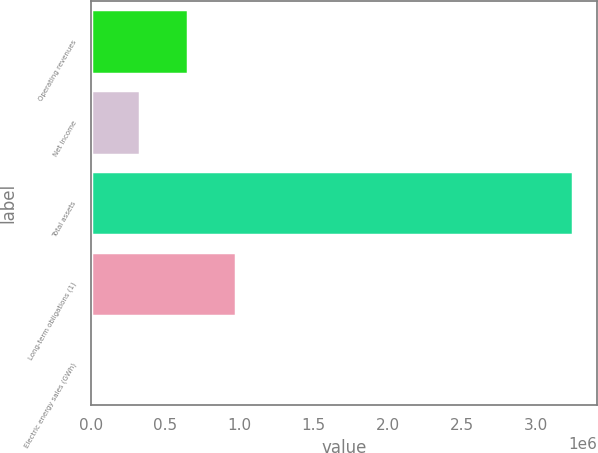<chart> <loc_0><loc_0><loc_500><loc_500><bar_chart><fcel>Operating revenues<fcel>Net Income<fcel>Total assets<fcel>Long-term obligations (1)<fcel>Electric energy sales (GWh)<nl><fcel>656507<fcel>332900<fcel>3.24536e+06<fcel>980115<fcel>9293<nl></chart> 